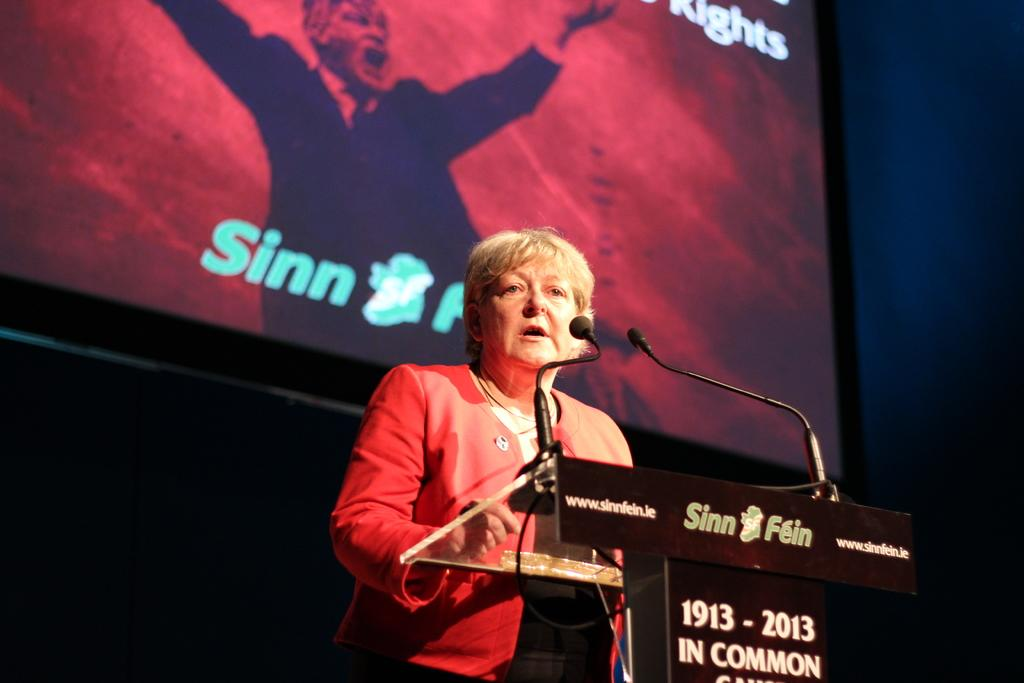<image>
Provide a brief description of the given image. A woman stands at a podium speaking, with Sinn Fein visible on the podium and on a screen behind it. 